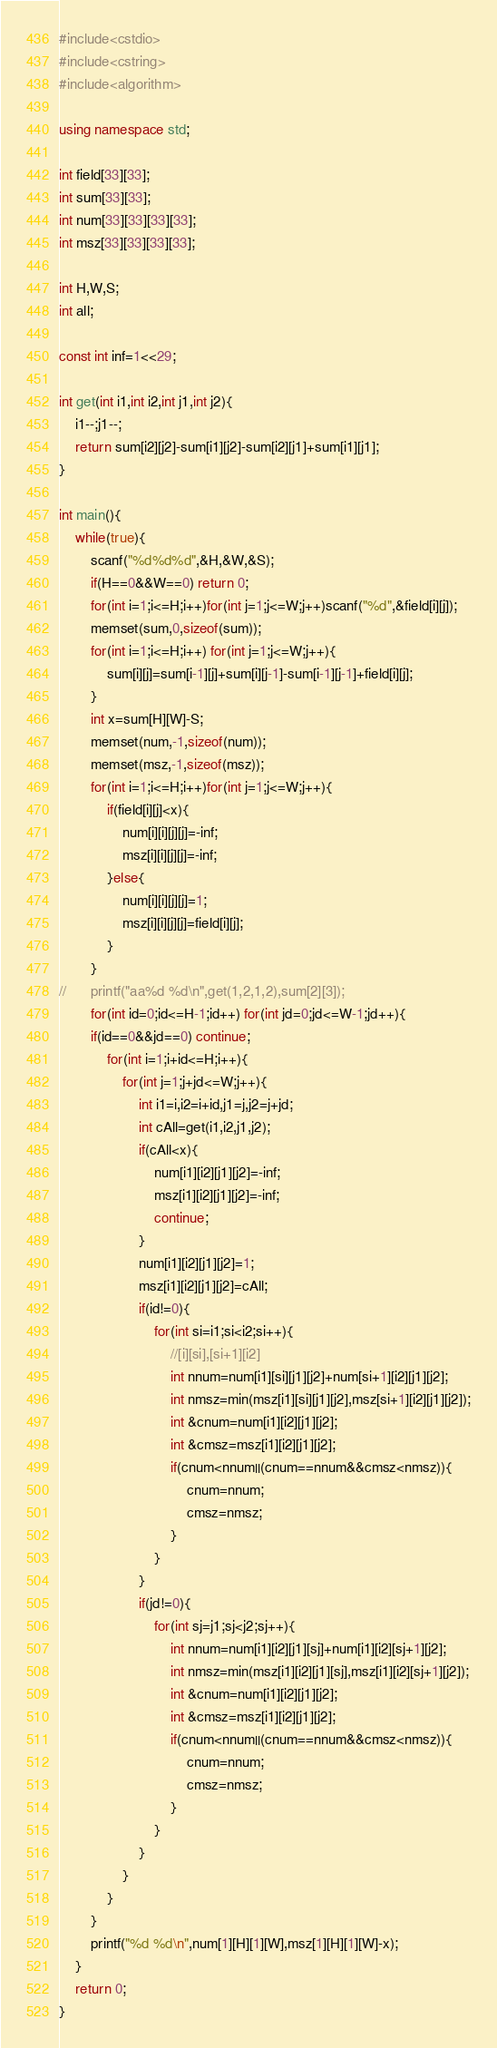Convert code to text. <code><loc_0><loc_0><loc_500><loc_500><_C++_>#include<cstdio>
#include<cstring>
#include<algorithm>

using namespace std;

int field[33][33];
int sum[33][33];
int num[33][33][33][33];
int msz[33][33][33][33];

int H,W,S;
int all;

const int inf=1<<29;

int get(int i1,int i2,int j1,int j2){
	i1--;j1--;
	return sum[i2][j2]-sum[i1][j2]-sum[i2][j1]+sum[i1][j1];
}

int main(){
	while(true){
		scanf("%d%d%d",&H,&W,&S);
		if(H==0&&W==0) return 0;
		for(int i=1;i<=H;i++)for(int j=1;j<=W;j++)scanf("%d",&field[i][j]);
		memset(sum,0,sizeof(sum));
		for(int i=1;i<=H;i++) for(int j=1;j<=W;j++){
			sum[i][j]=sum[i-1][j]+sum[i][j-1]-sum[i-1][j-1]+field[i][j];
		}
		int x=sum[H][W]-S;
		memset(num,-1,sizeof(num));
		memset(msz,-1,sizeof(msz));
		for(int i=1;i<=H;i++)for(int j=1;j<=W;j++){
			if(field[i][j]<x){
				num[i][i][j][j]=-inf;
				msz[i][i][j][j]=-inf;
			}else{
				num[i][i][j][j]=1;
				msz[i][i][j][j]=field[i][j];
			}
		}
//		printf("aa%d %d\n",get(1,2,1,2),sum[2][3]);
		for(int id=0;id<=H-1;id++) for(int jd=0;jd<=W-1;jd++){
		if(id==0&&jd==0) continue;
			for(int i=1;i+id<=H;i++){
				for(int j=1;j+jd<=W;j++){
					int i1=i,i2=i+id,j1=j,j2=j+jd;
					int cAll=get(i1,i2,j1,j2);
					if(cAll<x){
						num[i1][i2][j1][j2]=-inf;
						msz[i1][i2][j1][j2]=-inf;
						continue;
					}
					num[i1][i2][j1][j2]=1;
					msz[i1][i2][j1][j2]=cAll;
					if(id!=0){
						for(int si=i1;si<i2;si++){
							//[i][si],[si+1][i2]
							int nnum=num[i1][si][j1][j2]+num[si+1][i2][j1][j2];
							int nmsz=min(msz[i1][si][j1][j2],msz[si+1][i2][j1][j2]);
							int &cnum=num[i1][i2][j1][j2];
							int &cmsz=msz[i1][i2][j1][j2];
							if(cnum<nnum||(cnum==nnum&&cmsz<nmsz)){
								cnum=nnum;
								cmsz=nmsz;
							}
						}
					}
					if(jd!=0){
						for(int sj=j1;sj<j2;sj++){
							int nnum=num[i1][i2][j1][sj]+num[i1][i2][sj+1][j2];
							int nmsz=min(msz[i1][i2][j1][sj],msz[i1][i2][sj+1][j2]);
							int &cnum=num[i1][i2][j1][j2];
							int &cmsz=msz[i1][i2][j1][j2];
							if(cnum<nnum||(cnum==nnum&&cmsz<nmsz)){
								cnum=nnum;
								cmsz=nmsz;
							}
						}
					}
				}
			}
		}
		printf("%d %d\n",num[1][H][1][W],msz[1][H][1][W]-x);
	}
	return 0;
}</code> 